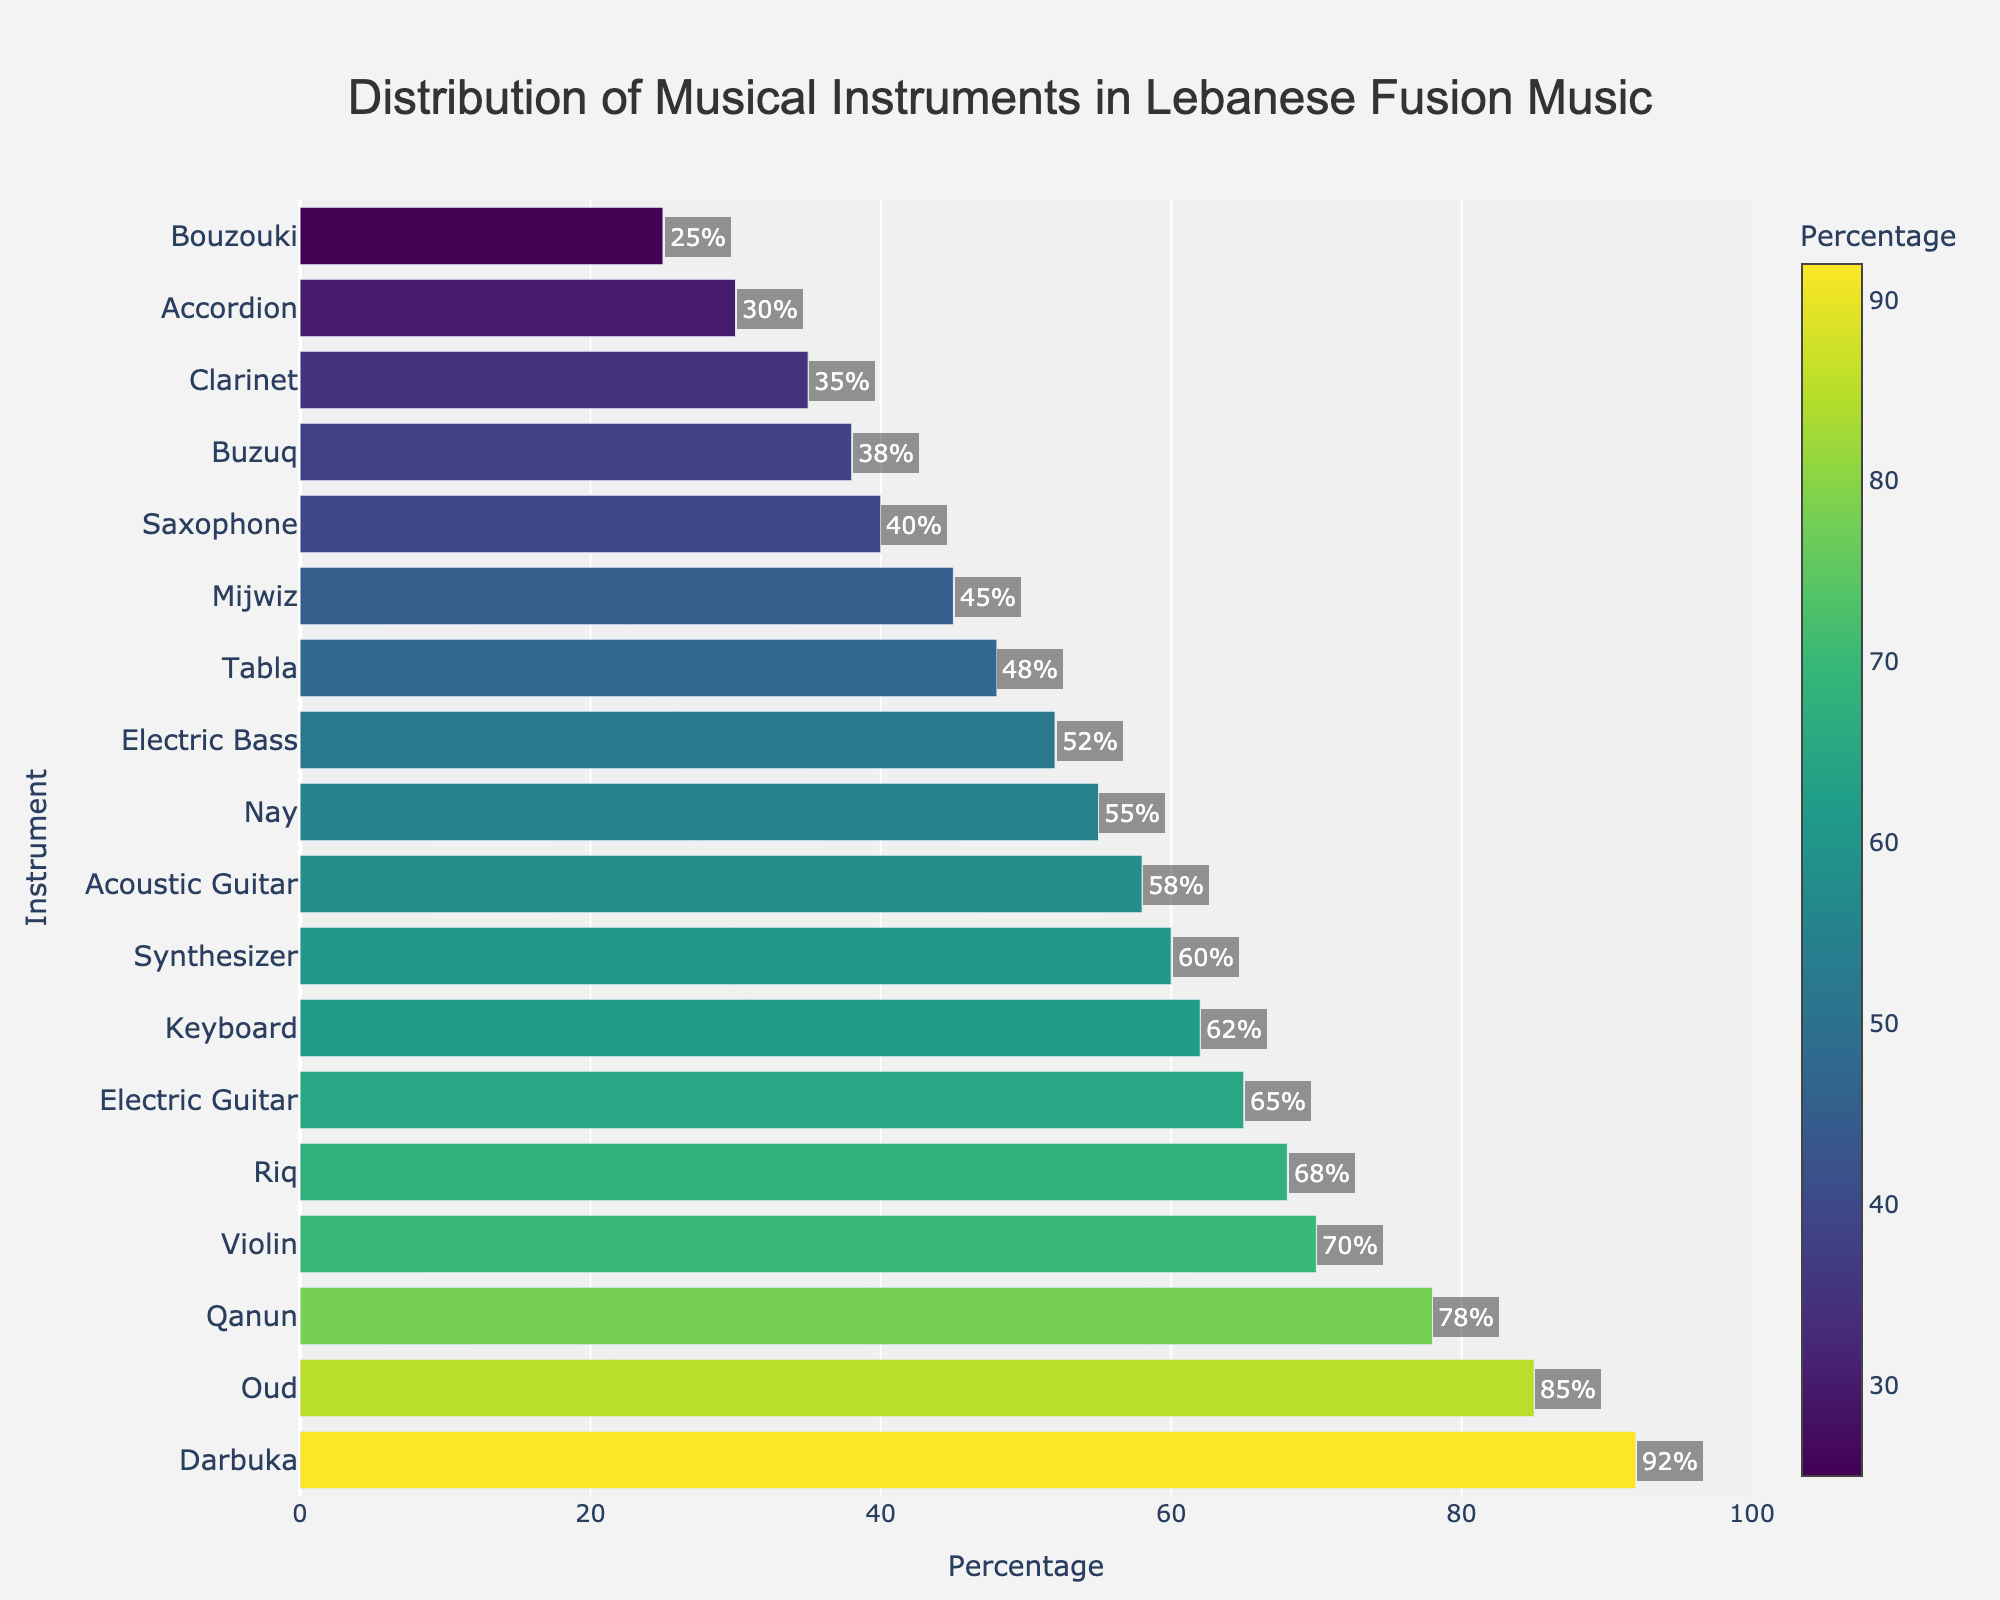Which instrument has the highest usage percentage in Lebanese fusion music? According to the figure, the Darbuka has the highest percentage among the musical instruments used.
Answer: Darbuka Which two instruments have a usage percentage of 58% and 55%? By observing the figure, Acoustic Guitar has a percentage of 58% and Nay has a percentage of 55%.
Answer: Acoustic Guitar and Nay What is the difference in usage percentage between the Oud and the Saxophone? The percentage for Oud is 85%, and the percentage for Saxophone is 40%. The difference is 85 - 40.
Answer: 45% What is the median percentage value for the instruments used? The sorted percentages are as follows: 25, 30, 35, 38, 40, 45, 48, 52, 55, 58, 60, 62, 65, 68, 70, 78, 85, 92. With an even number of instruments (18), the median is the average of the 9th and 10th values (55 and 58). So, (55+58)/2.
Answer: 56.5% How many instruments have a usage percentage greater than 60%? By observing the bar chart, there are seven instruments with usage percentages greater than 60%: Darbuka, Oud, Qanun, Violin, Electric Guitar, Keyboard, and Riq.
Answer: 7 instruments Which instrument is used less frequently: Clarinet or Buzuq? The figure shows that the Clarinet has a usage percentage of 35%, while the Buzuq has 38%. Thus, the Clarinet is used less frequently.
Answer: Clarinet What is the sum of the usage percentages for the Oud, Qanun, and Darbuka? The usage percentages for the Oud, Qanun, and Darbuka are 85%, 78%, and 92%, respectively. Adding them up gives 85 + 78 + 92.
Answer: 255% Which has a higher usage percentage: Synthesizer or Keyboard? According to the figure, the Synthesizer has 60% and the Keyboard has 62%. Therefore, the Keyboard has a higher percentage.
Answer: Keyboard What is the average usage percentage of the Nay, Mijwiz, and Tabla? The percentages for Nay, Mijwiz, and Tabla are 55%, 45%, and 48%, respectively. The average is calculated as (55 + 45 + 48) / 3.
Answer: 49.3% Which instrument falls between 40% and 50% in usage percentage? From the bar chart, the instruments that fall between 40% and 50% in usage are Saxophone, Mijwiz, and Tabla.
Answer: Saxophone, Mijwiz, and Tabla 